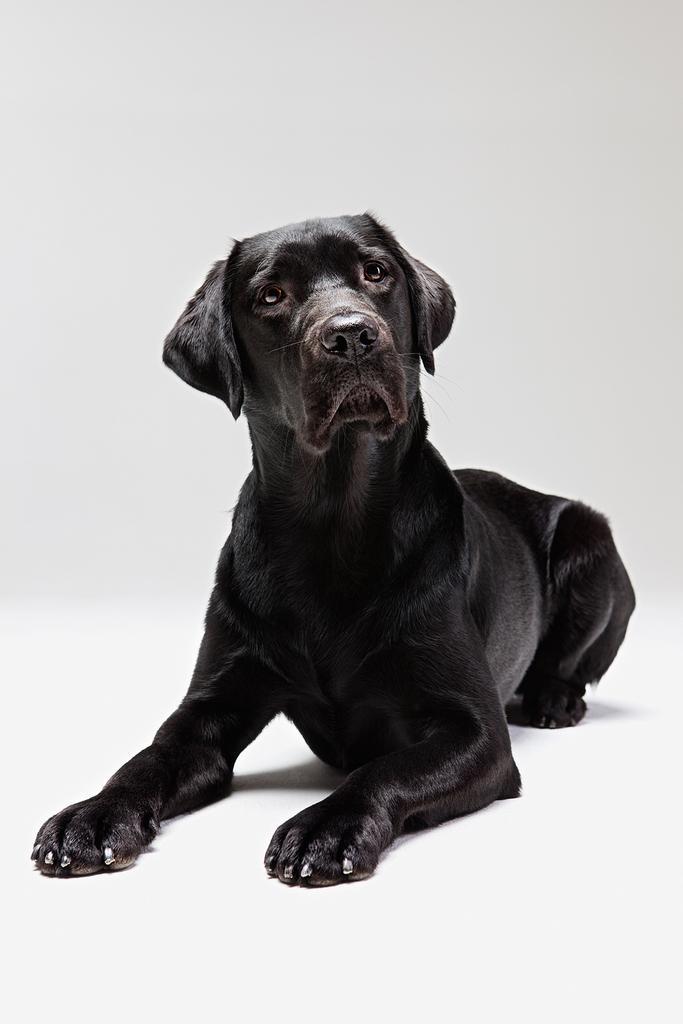In one or two sentences, can you explain what this image depicts? In this image we can see one black dog and the background is white in color. 